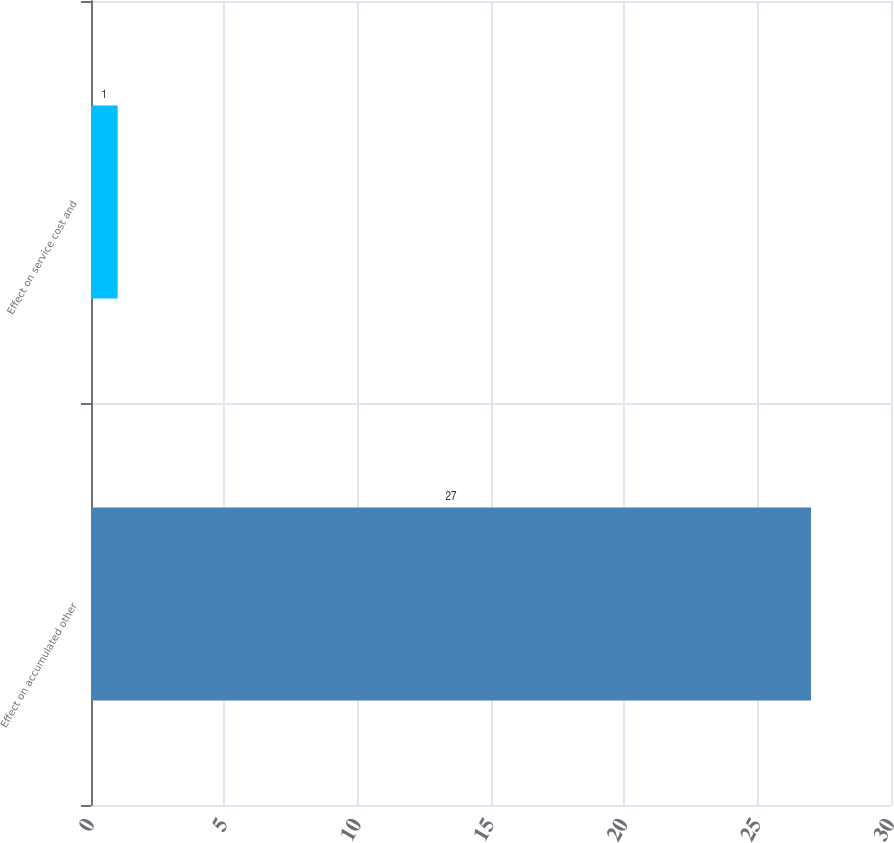<chart> <loc_0><loc_0><loc_500><loc_500><bar_chart><fcel>Effect on accumulated other<fcel>Effect on service cost and<nl><fcel>27<fcel>1<nl></chart> 